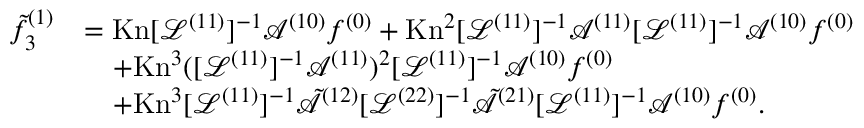<formula> <loc_0><loc_0><loc_500><loc_500>\begin{array} { r l } { \tilde { f } _ { 3 } ^ { ( 1 ) } } & { = K n [ \mathcal { L } ^ { ( 1 1 ) } ] ^ { - 1 } \mathcal { A } ^ { ( 1 0 ) } f ^ { ( 0 ) } + K n ^ { 2 } [ \mathcal { L } ^ { ( 1 1 ) } ] ^ { - 1 } \mathcal { A } ^ { ( 1 1 ) } [ \mathcal { L } ^ { ( 1 1 ) } ] ^ { - 1 } \mathcal { A } ^ { ( 1 0 ) } f ^ { ( 0 ) } } \\ & { \quad + K n ^ { 3 } ( [ \mathcal { L } ^ { ( 1 1 ) } ] ^ { - 1 } \mathcal { A } ^ { ( 1 1 ) } ) ^ { 2 } [ \mathcal { L } ^ { ( 1 1 ) } ] ^ { - 1 } \mathcal { A } ^ { ( 1 0 ) } f ^ { ( 0 ) } } \\ & { \quad + K n ^ { 3 } [ \mathcal { L } ^ { ( 1 1 ) } ] ^ { - 1 } \tilde { \mathcal { A } } ^ { ( 1 2 ) } [ \mathcal { L } ^ { ( 2 2 ) } ] ^ { - 1 } \tilde { \mathcal { A } } ^ { ( 2 1 ) } [ \mathcal { L } ^ { ( 1 1 ) } ] ^ { - 1 } \mathcal { A } ^ { ( 1 0 ) } f ^ { ( 0 ) } . } \end{array}</formula> 